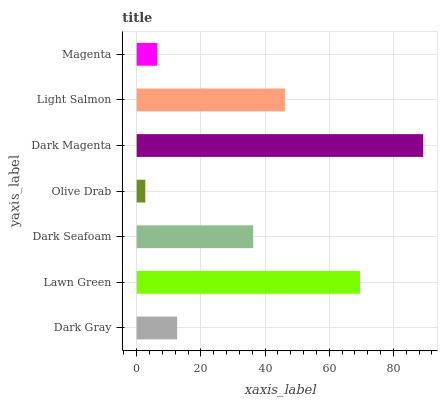Is Olive Drab the minimum?
Answer yes or no. Yes. Is Dark Magenta the maximum?
Answer yes or no. Yes. Is Lawn Green the minimum?
Answer yes or no. No. Is Lawn Green the maximum?
Answer yes or no. No. Is Lawn Green greater than Dark Gray?
Answer yes or no. Yes. Is Dark Gray less than Lawn Green?
Answer yes or no. Yes. Is Dark Gray greater than Lawn Green?
Answer yes or no. No. Is Lawn Green less than Dark Gray?
Answer yes or no. No. Is Dark Seafoam the high median?
Answer yes or no. Yes. Is Dark Seafoam the low median?
Answer yes or no. Yes. Is Light Salmon the high median?
Answer yes or no. No. Is Dark Magenta the low median?
Answer yes or no. No. 